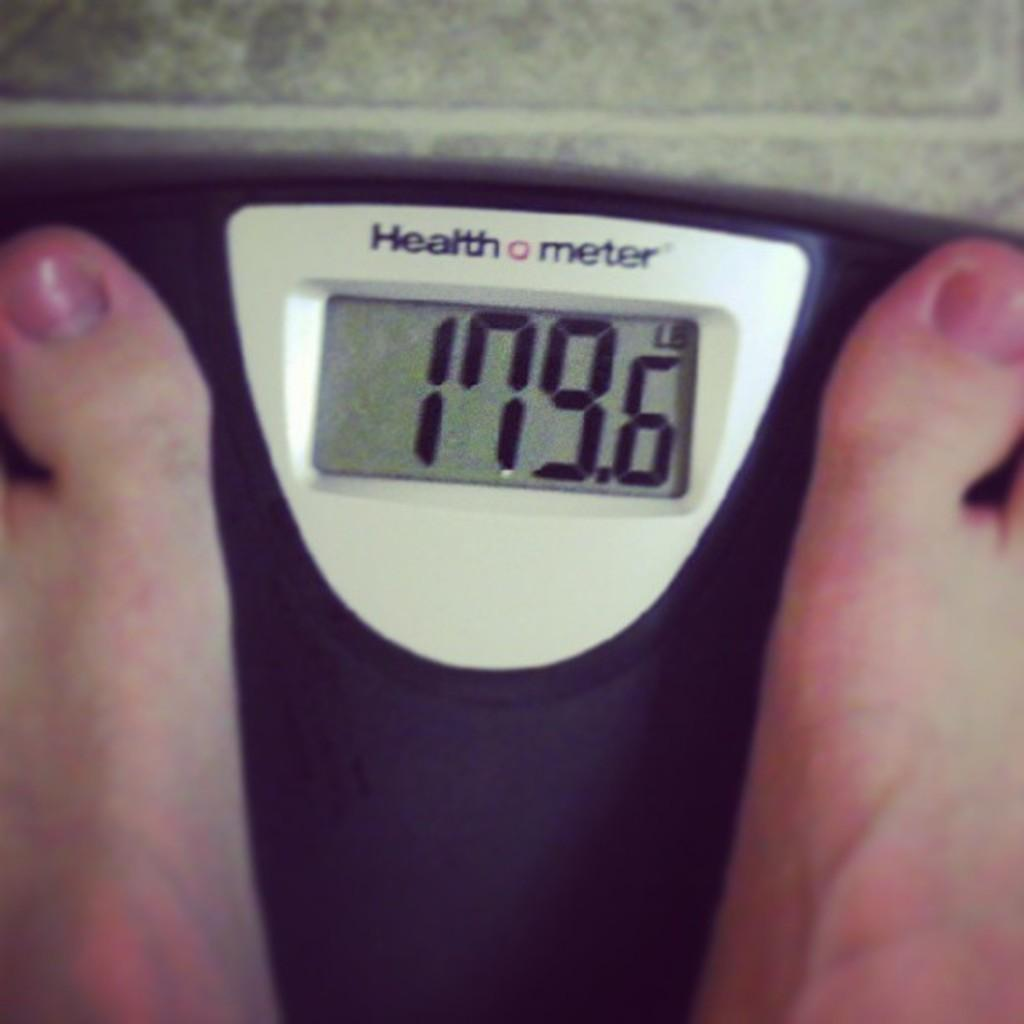<image>
Create a compact narrative representing the image presented. A person weighs 179.6 pounds according to the Health meter scale. 